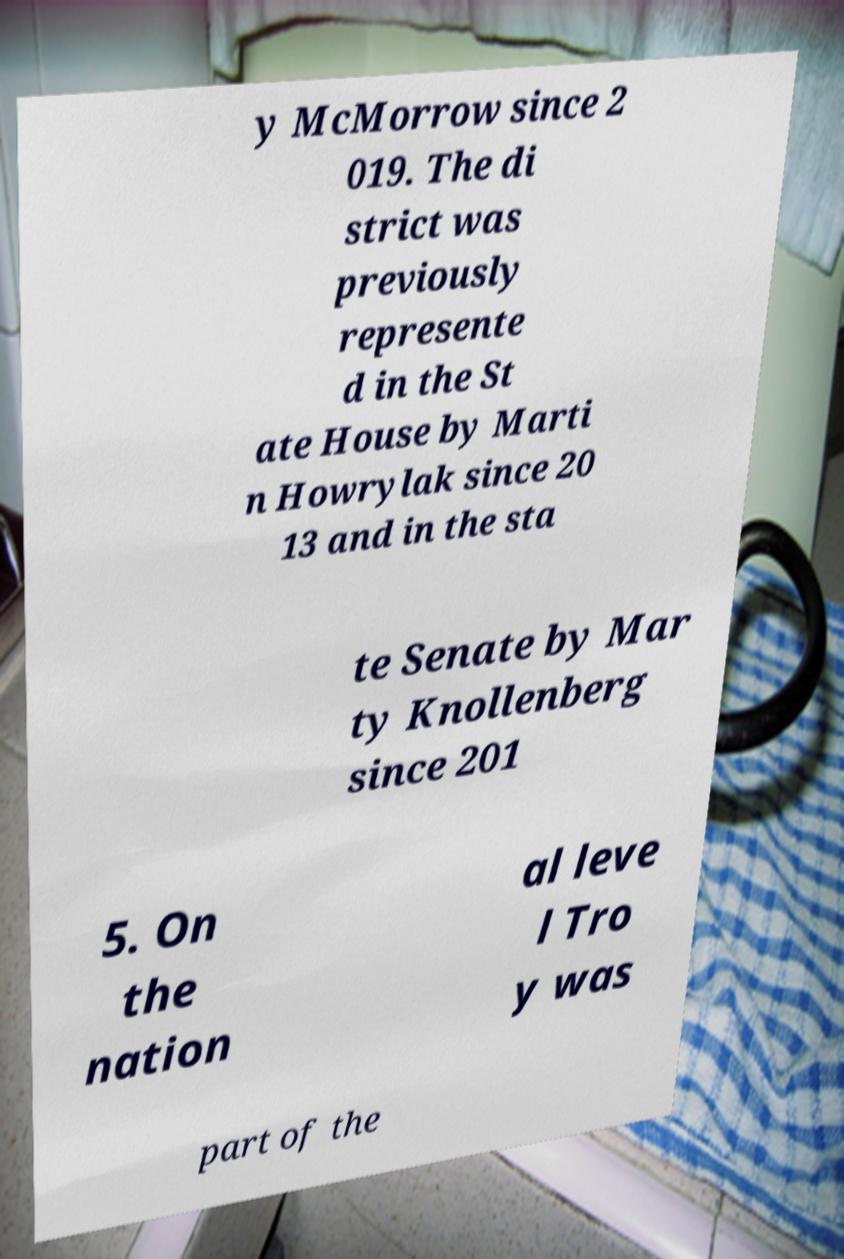Could you extract and type out the text from this image? y McMorrow since 2 019. The di strict was previously represente d in the St ate House by Marti n Howrylak since 20 13 and in the sta te Senate by Mar ty Knollenberg since 201 5. On the nation al leve l Tro y was part of the 